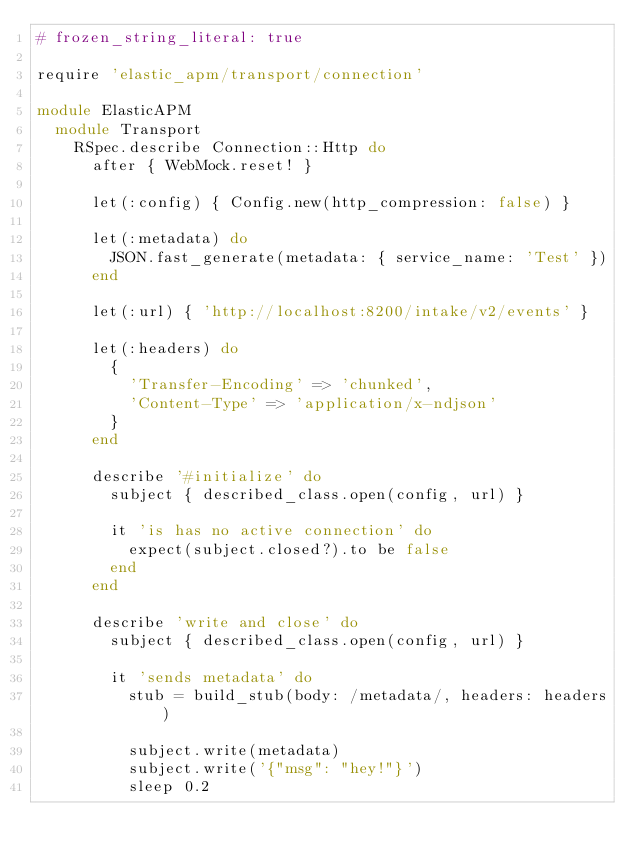Convert code to text. <code><loc_0><loc_0><loc_500><loc_500><_Ruby_># frozen_string_literal: true

require 'elastic_apm/transport/connection'

module ElasticAPM
  module Transport
    RSpec.describe Connection::Http do
      after { WebMock.reset! }

      let(:config) { Config.new(http_compression: false) }

      let(:metadata) do
        JSON.fast_generate(metadata: { service_name: 'Test' })
      end

      let(:url) { 'http://localhost:8200/intake/v2/events' }

      let(:headers) do
        {
          'Transfer-Encoding' => 'chunked',
          'Content-Type' => 'application/x-ndjson'
        }
      end

      describe '#initialize' do
        subject { described_class.open(config, url) }

        it 'is has no active connection' do
          expect(subject.closed?).to be false
        end
      end

      describe 'write and close' do
        subject { described_class.open(config, url) }

        it 'sends metadata' do
          stub = build_stub(body: /metadata/, headers: headers)

          subject.write(metadata)
          subject.write('{"msg": "hey!"}')
          sleep 0.2
</code> 